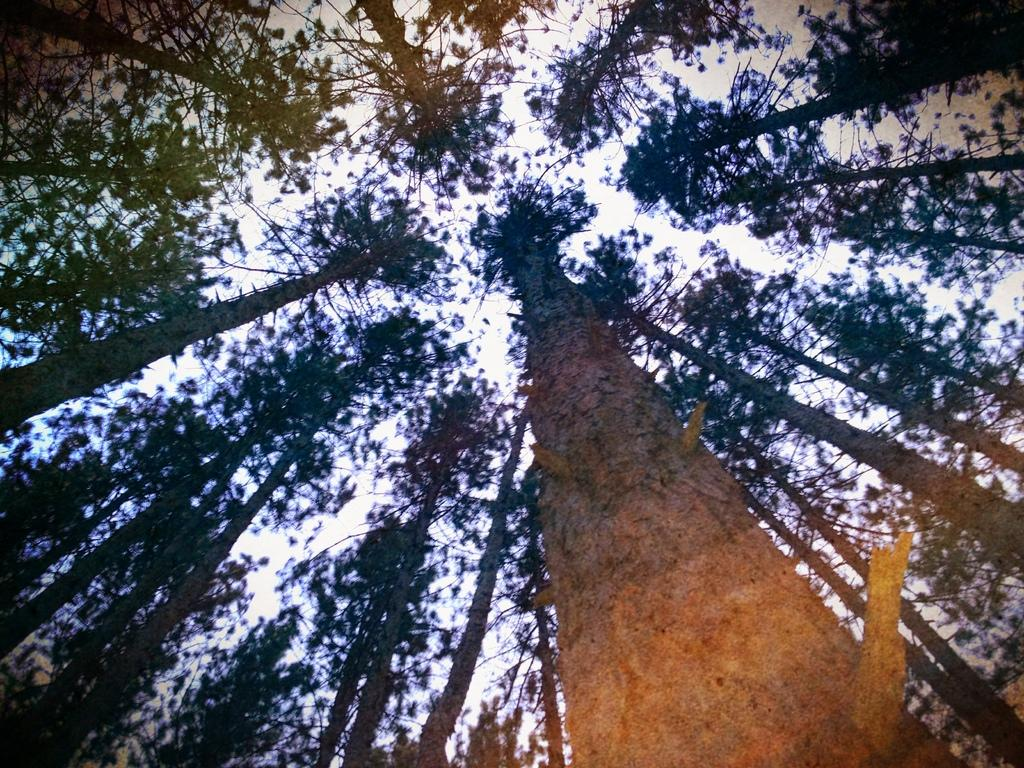What type of vegetation can be seen in the image? There are trees in the image. Can you describe the trees in the image? The provided facts do not include specific details about the trees, so we cannot describe them further. What type of stove is visible in the image? There is no stove present in the image; it only features trees. How many apples can be seen hanging from the trees in the image? There is no mention of apples in the image, so we cannot determine if any are present. 